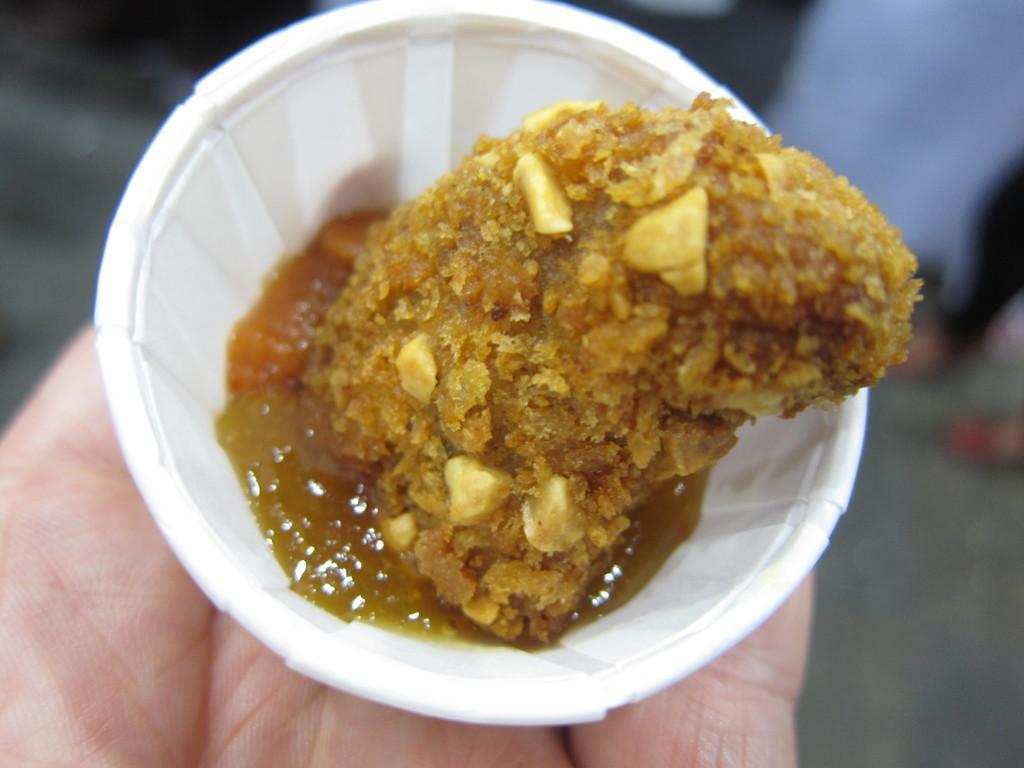Please provide a concise description of this image. In this image, we can see a person's hand holding a cup of food item. 